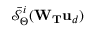<formula> <loc_0><loc_0><loc_500><loc_500>\bar { \mathcal { S } } _ { \Theta } ^ { i } ( W _ { T } u _ { d } )</formula> 